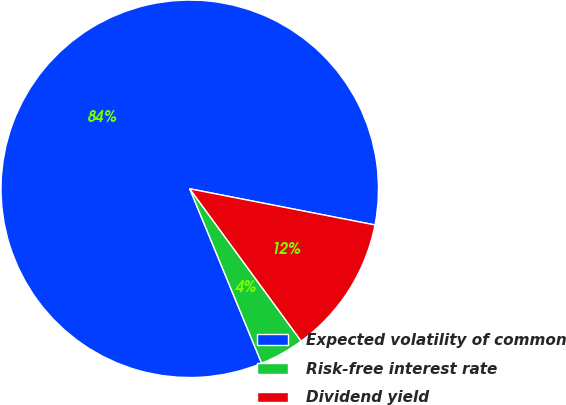Convert chart to OTSL. <chart><loc_0><loc_0><loc_500><loc_500><pie_chart><fcel>Expected volatility of common<fcel>Risk-free interest rate<fcel>Dividend yield<nl><fcel>84.29%<fcel>3.83%<fcel>11.88%<nl></chart> 